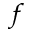Convert formula to latex. <formula><loc_0><loc_0><loc_500><loc_500>^ { f }</formula> 